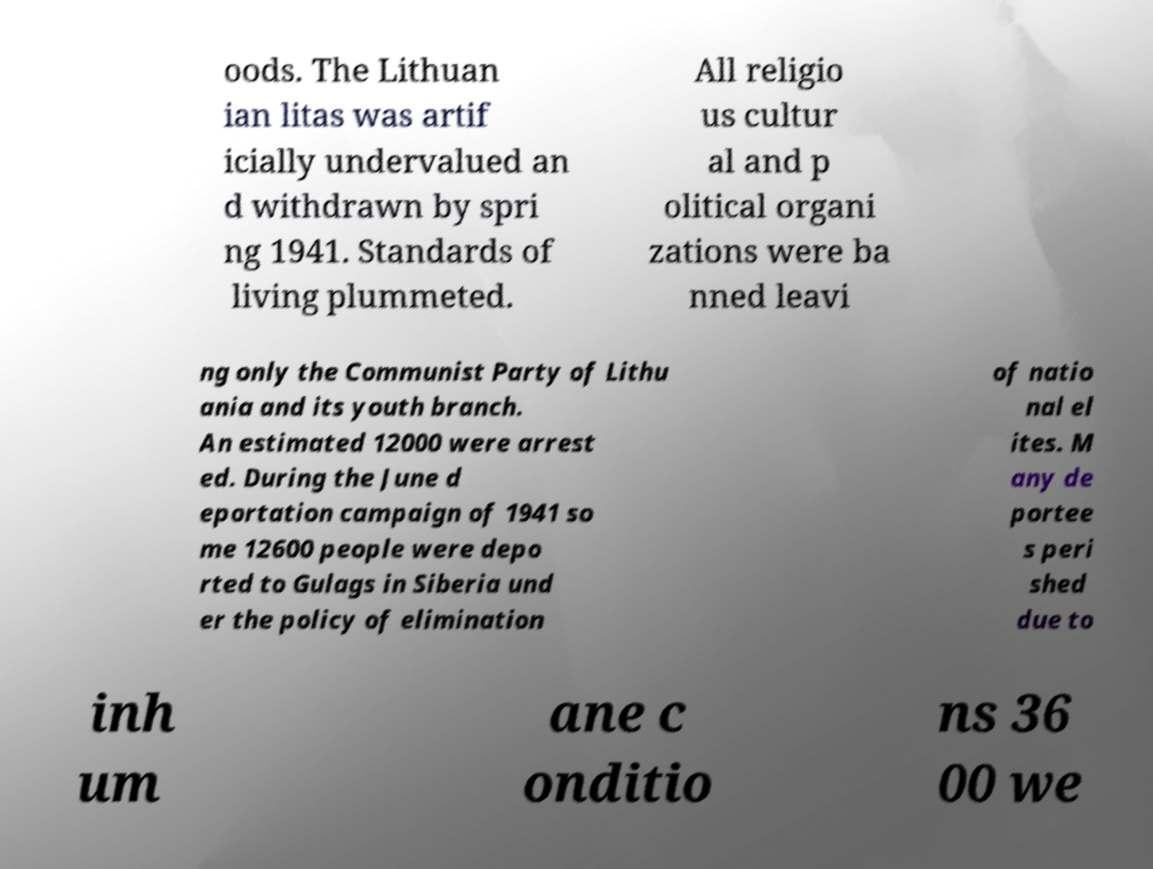Could you extract and type out the text from this image? oods. The Lithuan ian litas was artif icially undervalued an d withdrawn by spri ng 1941. Standards of living plummeted. All religio us cultur al and p olitical organi zations were ba nned leavi ng only the Communist Party of Lithu ania and its youth branch. An estimated 12000 were arrest ed. During the June d eportation campaign of 1941 so me 12600 people were depo rted to Gulags in Siberia und er the policy of elimination of natio nal el ites. M any de portee s peri shed due to inh um ane c onditio ns 36 00 we 